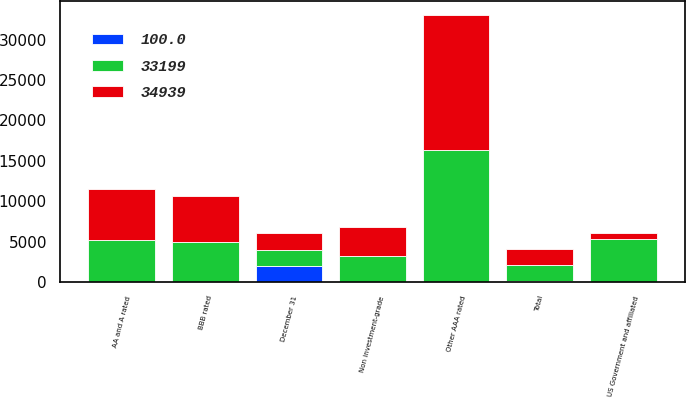<chart> <loc_0><loc_0><loc_500><loc_500><stacked_bar_chart><ecel><fcel>December 31<fcel>US Government and affiliated<fcel>Other AAA rated<fcel>AA and A rated<fcel>BBB rated<fcel>Non investment-grade<fcel>Total<nl><fcel>34939<fcel>2007<fcel>816<fcel>16728<fcel>6326<fcel>5713<fcel>3616<fcel>2007<nl><fcel>100<fcel>2007<fcel>2.5<fcel>50.4<fcel>19.1<fcel>17.2<fcel>10.8<fcel>100<nl><fcel>33199<fcel>2006<fcel>5285<fcel>16311<fcel>5222<fcel>4933<fcel>3188<fcel>2007<nl></chart> 